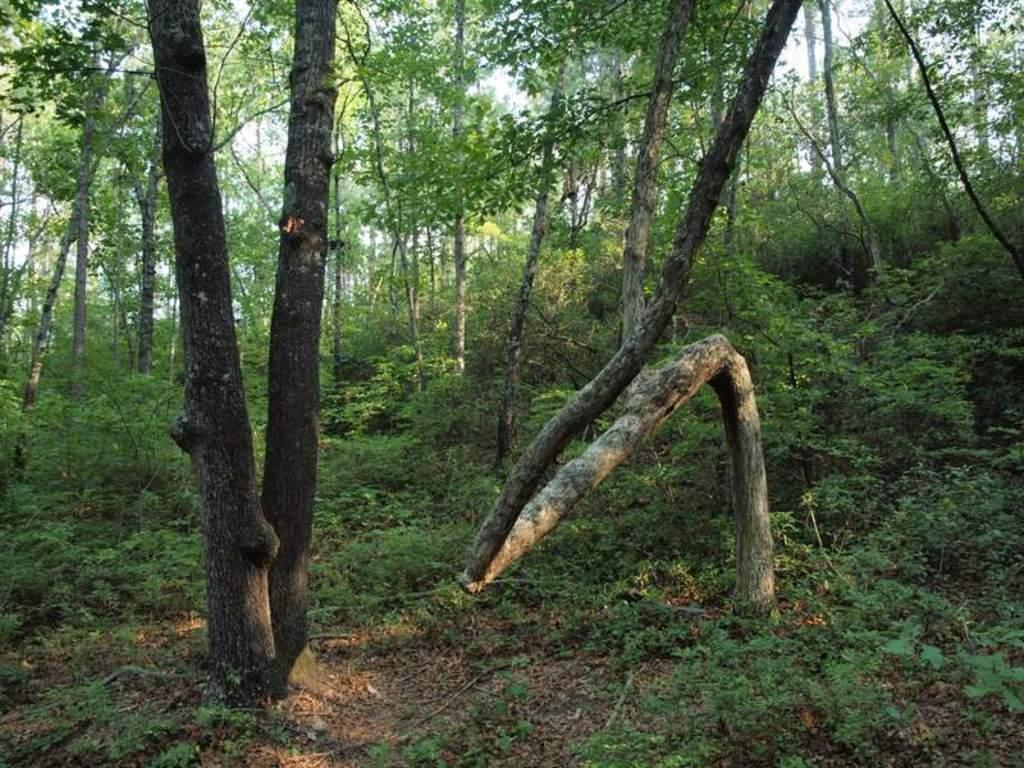What type of ground covering is visible in the image? The ground is covered with grass. What type of vegetation can be seen in the image? There are plants and trees in the image. What is visible in the background of the image? The sky is visible in the image. How does the manager feel about the plants in the image? There is no manager present in the image, so it is not possible to determine their feelings about the plants. 